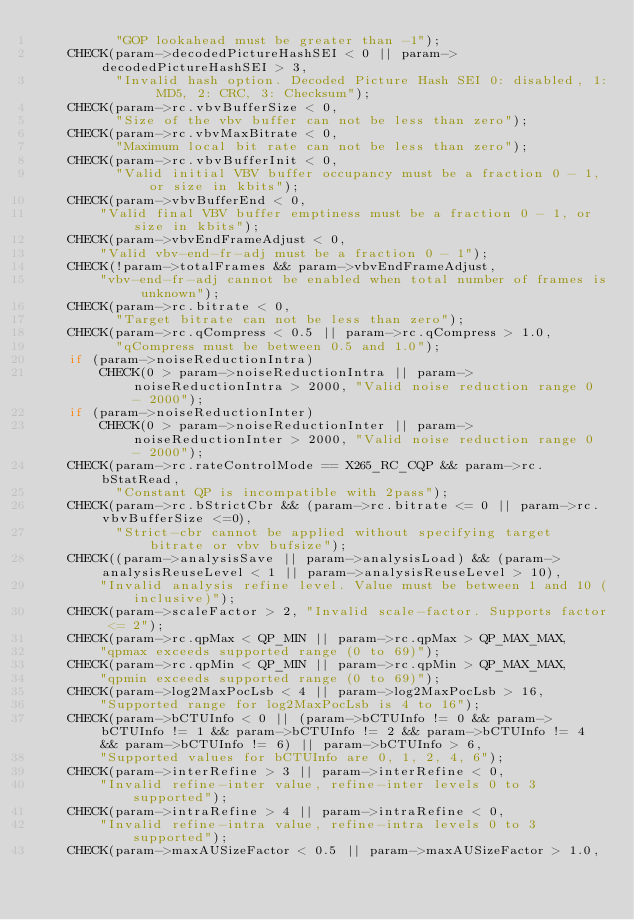<code> <loc_0><loc_0><loc_500><loc_500><_C++_>          "GOP lookahead must be greater than -1");
    CHECK(param->decodedPictureHashSEI < 0 || param->decodedPictureHashSEI > 3,
          "Invalid hash option. Decoded Picture Hash SEI 0: disabled, 1: MD5, 2: CRC, 3: Checksum");
    CHECK(param->rc.vbvBufferSize < 0,
          "Size of the vbv buffer can not be less than zero");
    CHECK(param->rc.vbvMaxBitrate < 0,
          "Maximum local bit rate can not be less than zero");
    CHECK(param->rc.vbvBufferInit < 0,
          "Valid initial VBV buffer occupancy must be a fraction 0 - 1, or size in kbits");
    CHECK(param->vbvBufferEnd < 0,
        "Valid final VBV buffer emptiness must be a fraction 0 - 1, or size in kbits");
    CHECK(param->vbvEndFrameAdjust < 0,
        "Valid vbv-end-fr-adj must be a fraction 0 - 1");
    CHECK(!param->totalFrames && param->vbvEndFrameAdjust,
        "vbv-end-fr-adj cannot be enabled when total number of frames is unknown");
    CHECK(param->rc.bitrate < 0,
          "Target bitrate can not be less than zero");
    CHECK(param->rc.qCompress < 0.5 || param->rc.qCompress > 1.0,
          "qCompress must be between 0.5 and 1.0");
    if (param->noiseReductionIntra)
        CHECK(0 > param->noiseReductionIntra || param->noiseReductionIntra > 2000, "Valid noise reduction range 0 - 2000");
    if (param->noiseReductionInter)
        CHECK(0 > param->noiseReductionInter || param->noiseReductionInter > 2000, "Valid noise reduction range 0 - 2000");
    CHECK(param->rc.rateControlMode == X265_RC_CQP && param->rc.bStatRead,
          "Constant QP is incompatible with 2pass");
    CHECK(param->rc.bStrictCbr && (param->rc.bitrate <= 0 || param->rc.vbvBufferSize <=0),
          "Strict-cbr cannot be applied without specifying target bitrate or vbv bufsize");
    CHECK((param->analysisSave || param->analysisLoad) && (param->analysisReuseLevel < 1 || param->analysisReuseLevel > 10),
        "Invalid analysis refine level. Value must be between 1 and 10 (inclusive)");
    CHECK(param->scaleFactor > 2, "Invalid scale-factor. Supports factor <= 2");
    CHECK(param->rc.qpMax < QP_MIN || param->rc.qpMax > QP_MAX_MAX,
        "qpmax exceeds supported range (0 to 69)");
    CHECK(param->rc.qpMin < QP_MIN || param->rc.qpMin > QP_MAX_MAX,
        "qpmin exceeds supported range (0 to 69)");
    CHECK(param->log2MaxPocLsb < 4 || param->log2MaxPocLsb > 16,
        "Supported range for log2MaxPocLsb is 4 to 16");
    CHECK(param->bCTUInfo < 0 || (param->bCTUInfo != 0 && param->bCTUInfo != 1 && param->bCTUInfo != 2 && param->bCTUInfo != 4 && param->bCTUInfo != 6) || param->bCTUInfo > 6,
        "Supported values for bCTUInfo are 0, 1, 2, 4, 6");
    CHECK(param->interRefine > 3 || param->interRefine < 0,
        "Invalid refine-inter value, refine-inter levels 0 to 3 supported");
    CHECK(param->intraRefine > 4 || param->intraRefine < 0,
        "Invalid refine-intra value, refine-intra levels 0 to 3 supported");
    CHECK(param->maxAUSizeFactor < 0.5 || param->maxAUSizeFactor > 1.0,</code> 